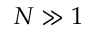Convert formula to latex. <formula><loc_0><loc_0><loc_500><loc_500>N \gg 1</formula> 